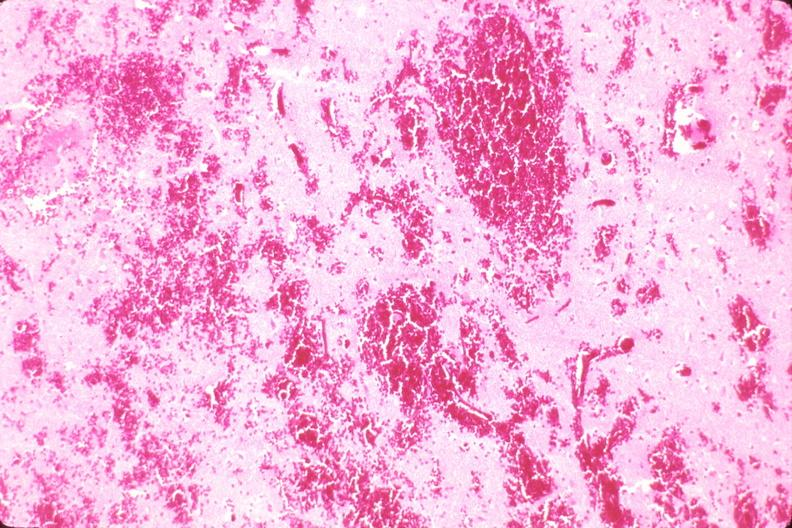does this image show brain, intraparenchymal hemorrhage due to ruptured aneurysm?
Answer the question using a single word or phrase. Yes 